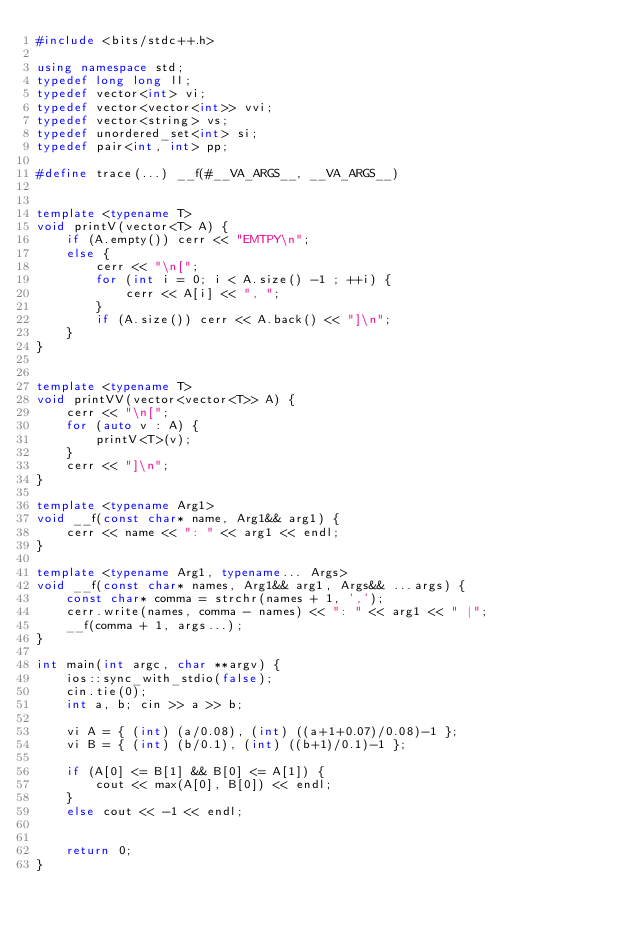<code> <loc_0><loc_0><loc_500><loc_500><_C++_>#include <bits/stdc++.h>

using namespace std;
typedef long long ll;
typedef vector<int> vi;
typedef vector<vector<int>> vvi;
typedef vector<string> vs;
typedef unordered_set<int> si;
typedef pair<int, int> pp;

#define trace(...) __f(#__VA_ARGS__, __VA_ARGS__)


template <typename T>
void printV(vector<T> A) {
    if (A.empty()) cerr << "EMTPY\n";
    else { 
        cerr << "\n[";
        for (int i = 0; i < A.size() -1 ; ++i) {
            cerr << A[i] << ", ";
        }
        if (A.size()) cerr << A.back() << "]\n";
    }
}


template <typename T>
void printVV(vector<vector<T>> A) {
    cerr << "\n[";
    for (auto v : A) {
        printV<T>(v);
    }
    cerr << "]\n";
}

template <typename Arg1>
void __f(const char* name, Arg1&& arg1) {
    cerr << name << ": " << arg1 << endl;
}

template <typename Arg1, typename... Args>
void __f(const char* names, Arg1&& arg1, Args&& ...args) {
    const char* comma = strchr(names + 1, ',');
    cerr.write(names, comma - names) << ": " << arg1 << " |";
    __f(comma + 1, args...);
}

int main(int argc, char **argv) {
    ios::sync_with_stdio(false);
    cin.tie(0);
    int a, b; cin >> a >> b;
    
    vi A = { (int) (a/0.08), (int) ((a+1+0.07)/0.08)-1 };
    vi B = { (int) (b/0.1), (int) ((b+1)/0.1)-1 };

    if (A[0] <= B[1] && B[0] <= A[1]) {
        cout << max(A[0], B[0]) << endl;
    }
    else cout << -1 << endl;


    return 0;
}

</code> 